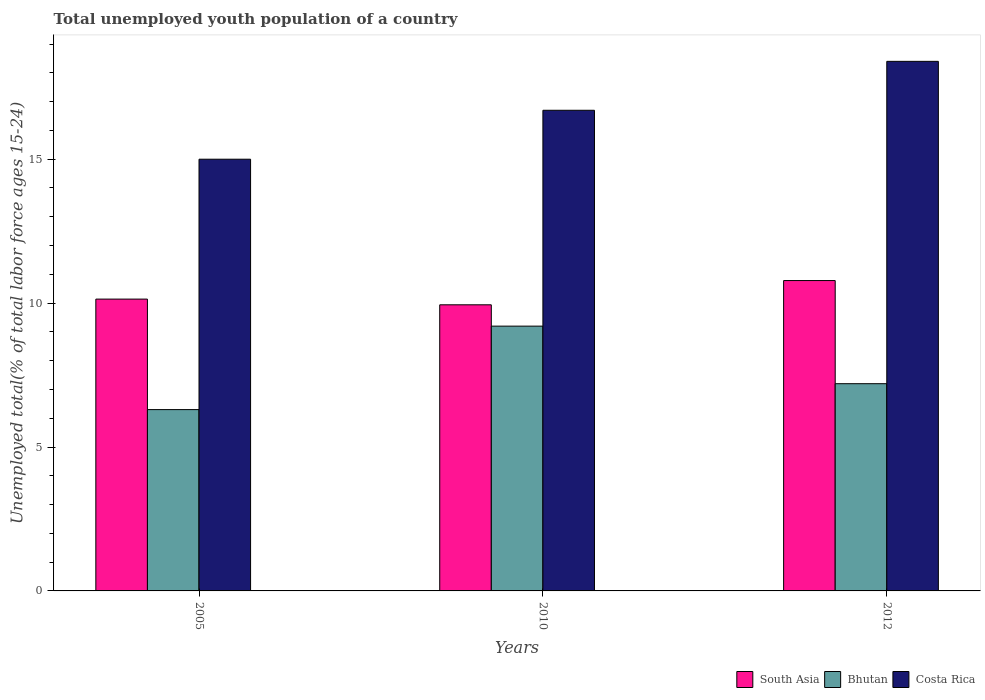How many different coloured bars are there?
Your answer should be compact. 3. How many groups of bars are there?
Your answer should be compact. 3. Are the number of bars on each tick of the X-axis equal?
Provide a short and direct response. Yes. How many bars are there on the 1st tick from the left?
Offer a very short reply. 3. How many bars are there on the 1st tick from the right?
Give a very brief answer. 3. In how many cases, is the number of bars for a given year not equal to the number of legend labels?
Keep it short and to the point. 0. What is the percentage of total unemployed youth population of a country in Bhutan in 2012?
Offer a terse response. 7.2. Across all years, what is the maximum percentage of total unemployed youth population of a country in Costa Rica?
Ensure brevity in your answer.  18.4. Across all years, what is the minimum percentage of total unemployed youth population of a country in Bhutan?
Offer a very short reply. 6.3. In which year was the percentage of total unemployed youth population of a country in Bhutan maximum?
Provide a short and direct response. 2010. In which year was the percentage of total unemployed youth population of a country in Bhutan minimum?
Ensure brevity in your answer.  2005. What is the total percentage of total unemployed youth population of a country in South Asia in the graph?
Provide a short and direct response. 30.86. What is the difference between the percentage of total unemployed youth population of a country in Costa Rica in 2005 and that in 2010?
Ensure brevity in your answer.  -1.7. What is the difference between the percentage of total unemployed youth population of a country in South Asia in 2010 and the percentage of total unemployed youth population of a country in Bhutan in 2005?
Offer a very short reply. 3.64. What is the average percentage of total unemployed youth population of a country in South Asia per year?
Ensure brevity in your answer.  10.29. In the year 2005, what is the difference between the percentage of total unemployed youth population of a country in Costa Rica and percentage of total unemployed youth population of a country in Bhutan?
Your response must be concise. 8.7. In how many years, is the percentage of total unemployed youth population of a country in Costa Rica greater than 16 %?
Provide a short and direct response. 2. What is the ratio of the percentage of total unemployed youth population of a country in South Asia in 2010 to that in 2012?
Your answer should be compact. 0.92. Is the difference between the percentage of total unemployed youth population of a country in Costa Rica in 2005 and 2010 greater than the difference between the percentage of total unemployed youth population of a country in Bhutan in 2005 and 2010?
Your answer should be compact. Yes. What is the difference between the highest and the second highest percentage of total unemployed youth population of a country in Bhutan?
Give a very brief answer. 2. What is the difference between the highest and the lowest percentage of total unemployed youth population of a country in Bhutan?
Make the answer very short. 2.9. Is the sum of the percentage of total unemployed youth population of a country in Costa Rica in 2005 and 2010 greater than the maximum percentage of total unemployed youth population of a country in South Asia across all years?
Keep it short and to the point. Yes. What does the 3rd bar from the left in 2010 represents?
Keep it short and to the point. Costa Rica. What does the 3rd bar from the right in 2012 represents?
Your answer should be very brief. South Asia. Are all the bars in the graph horizontal?
Your response must be concise. No. How many years are there in the graph?
Offer a terse response. 3. Are the values on the major ticks of Y-axis written in scientific E-notation?
Provide a short and direct response. No. Does the graph contain any zero values?
Provide a short and direct response. No. Does the graph contain grids?
Keep it short and to the point. No. How are the legend labels stacked?
Ensure brevity in your answer.  Horizontal. What is the title of the graph?
Offer a very short reply. Total unemployed youth population of a country. What is the label or title of the Y-axis?
Offer a terse response. Unemployed total(% of total labor force ages 15-24). What is the Unemployed total(% of total labor force ages 15-24) in South Asia in 2005?
Provide a short and direct response. 10.14. What is the Unemployed total(% of total labor force ages 15-24) in Bhutan in 2005?
Your answer should be compact. 6.3. What is the Unemployed total(% of total labor force ages 15-24) of Costa Rica in 2005?
Provide a succinct answer. 15. What is the Unemployed total(% of total labor force ages 15-24) of South Asia in 2010?
Your answer should be compact. 9.94. What is the Unemployed total(% of total labor force ages 15-24) of Bhutan in 2010?
Offer a very short reply. 9.2. What is the Unemployed total(% of total labor force ages 15-24) of Costa Rica in 2010?
Keep it short and to the point. 16.7. What is the Unemployed total(% of total labor force ages 15-24) in South Asia in 2012?
Offer a very short reply. 10.78. What is the Unemployed total(% of total labor force ages 15-24) of Bhutan in 2012?
Your answer should be compact. 7.2. What is the Unemployed total(% of total labor force ages 15-24) of Costa Rica in 2012?
Offer a terse response. 18.4. Across all years, what is the maximum Unemployed total(% of total labor force ages 15-24) of South Asia?
Provide a succinct answer. 10.78. Across all years, what is the maximum Unemployed total(% of total labor force ages 15-24) in Bhutan?
Your answer should be very brief. 9.2. Across all years, what is the maximum Unemployed total(% of total labor force ages 15-24) of Costa Rica?
Ensure brevity in your answer.  18.4. Across all years, what is the minimum Unemployed total(% of total labor force ages 15-24) of South Asia?
Your response must be concise. 9.94. Across all years, what is the minimum Unemployed total(% of total labor force ages 15-24) of Bhutan?
Your response must be concise. 6.3. What is the total Unemployed total(% of total labor force ages 15-24) of South Asia in the graph?
Offer a very short reply. 30.86. What is the total Unemployed total(% of total labor force ages 15-24) in Bhutan in the graph?
Keep it short and to the point. 22.7. What is the total Unemployed total(% of total labor force ages 15-24) in Costa Rica in the graph?
Provide a succinct answer. 50.1. What is the difference between the Unemployed total(% of total labor force ages 15-24) of South Asia in 2005 and that in 2010?
Your answer should be compact. 0.2. What is the difference between the Unemployed total(% of total labor force ages 15-24) of Bhutan in 2005 and that in 2010?
Provide a short and direct response. -2.9. What is the difference between the Unemployed total(% of total labor force ages 15-24) in South Asia in 2005 and that in 2012?
Provide a short and direct response. -0.64. What is the difference between the Unemployed total(% of total labor force ages 15-24) in Bhutan in 2005 and that in 2012?
Provide a succinct answer. -0.9. What is the difference between the Unemployed total(% of total labor force ages 15-24) in South Asia in 2010 and that in 2012?
Make the answer very short. -0.84. What is the difference between the Unemployed total(% of total labor force ages 15-24) in Bhutan in 2010 and that in 2012?
Your response must be concise. 2. What is the difference between the Unemployed total(% of total labor force ages 15-24) in Costa Rica in 2010 and that in 2012?
Offer a terse response. -1.7. What is the difference between the Unemployed total(% of total labor force ages 15-24) in South Asia in 2005 and the Unemployed total(% of total labor force ages 15-24) in Bhutan in 2010?
Offer a terse response. 0.94. What is the difference between the Unemployed total(% of total labor force ages 15-24) in South Asia in 2005 and the Unemployed total(% of total labor force ages 15-24) in Costa Rica in 2010?
Keep it short and to the point. -6.56. What is the difference between the Unemployed total(% of total labor force ages 15-24) of Bhutan in 2005 and the Unemployed total(% of total labor force ages 15-24) of Costa Rica in 2010?
Provide a succinct answer. -10.4. What is the difference between the Unemployed total(% of total labor force ages 15-24) of South Asia in 2005 and the Unemployed total(% of total labor force ages 15-24) of Bhutan in 2012?
Provide a short and direct response. 2.94. What is the difference between the Unemployed total(% of total labor force ages 15-24) in South Asia in 2005 and the Unemployed total(% of total labor force ages 15-24) in Costa Rica in 2012?
Your response must be concise. -8.26. What is the difference between the Unemployed total(% of total labor force ages 15-24) of South Asia in 2010 and the Unemployed total(% of total labor force ages 15-24) of Bhutan in 2012?
Your answer should be very brief. 2.74. What is the difference between the Unemployed total(% of total labor force ages 15-24) in South Asia in 2010 and the Unemployed total(% of total labor force ages 15-24) in Costa Rica in 2012?
Offer a terse response. -8.46. What is the difference between the Unemployed total(% of total labor force ages 15-24) in Bhutan in 2010 and the Unemployed total(% of total labor force ages 15-24) in Costa Rica in 2012?
Offer a very short reply. -9.2. What is the average Unemployed total(% of total labor force ages 15-24) in South Asia per year?
Provide a short and direct response. 10.29. What is the average Unemployed total(% of total labor force ages 15-24) of Bhutan per year?
Offer a terse response. 7.57. What is the average Unemployed total(% of total labor force ages 15-24) of Costa Rica per year?
Make the answer very short. 16.7. In the year 2005, what is the difference between the Unemployed total(% of total labor force ages 15-24) in South Asia and Unemployed total(% of total labor force ages 15-24) in Bhutan?
Ensure brevity in your answer.  3.84. In the year 2005, what is the difference between the Unemployed total(% of total labor force ages 15-24) in South Asia and Unemployed total(% of total labor force ages 15-24) in Costa Rica?
Ensure brevity in your answer.  -4.86. In the year 2005, what is the difference between the Unemployed total(% of total labor force ages 15-24) of Bhutan and Unemployed total(% of total labor force ages 15-24) of Costa Rica?
Keep it short and to the point. -8.7. In the year 2010, what is the difference between the Unemployed total(% of total labor force ages 15-24) of South Asia and Unemployed total(% of total labor force ages 15-24) of Bhutan?
Keep it short and to the point. 0.74. In the year 2010, what is the difference between the Unemployed total(% of total labor force ages 15-24) in South Asia and Unemployed total(% of total labor force ages 15-24) in Costa Rica?
Offer a terse response. -6.76. In the year 2012, what is the difference between the Unemployed total(% of total labor force ages 15-24) of South Asia and Unemployed total(% of total labor force ages 15-24) of Bhutan?
Give a very brief answer. 3.58. In the year 2012, what is the difference between the Unemployed total(% of total labor force ages 15-24) of South Asia and Unemployed total(% of total labor force ages 15-24) of Costa Rica?
Offer a very short reply. -7.62. What is the ratio of the Unemployed total(% of total labor force ages 15-24) in South Asia in 2005 to that in 2010?
Offer a very short reply. 1.02. What is the ratio of the Unemployed total(% of total labor force ages 15-24) in Bhutan in 2005 to that in 2010?
Keep it short and to the point. 0.68. What is the ratio of the Unemployed total(% of total labor force ages 15-24) of Costa Rica in 2005 to that in 2010?
Provide a succinct answer. 0.9. What is the ratio of the Unemployed total(% of total labor force ages 15-24) of South Asia in 2005 to that in 2012?
Your answer should be very brief. 0.94. What is the ratio of the Unemployed total(% of total labor force ages 15-24) of Bhutan in 2005 to that in 2012?
Give a very brief answer. 0.88. What is the ratio of the Unemployed total(% of total labor force ages 15-24) in Costa Rica in 2005 to that in 2012?
Give a very brief answer. 0.82. What is the ratio of the Unemployed total(% of total labor force ages 15-24) in South Asia in 2010 to that in 2012?
Offer a very short reply. 0.92. What is the ratio of the Unemployed total(% of total labor force ages 15-24) of Bhutan in 2010 to that in 2012?
Ensure brevity in your answer.  1.28. What is the ratio of the Unemployed total(% of total labor force ages 15-24) in Costa Rica in 2010 to that in 2012?
Ensure brevity in your answer.  0.91. What is the difference between the highest and the second highest Unemployed total(% of total labor force ages 15-24) in South Asia?
Keep it short and to the point. 0.64. What is the difference between the highest and the second highest Unemployed total(% of total labor force ages 15-24) of Bhutan?
Keep it short and to the point. 2. What is the difference between the highest and the lowest Unemployed total(% of total labor force ages 15-24) of South Asia?
Your answer should be compact. 0.84. What is the difference between the highest and the lowest Unemployed total(% of total labor force ages 15-24) in Costa Rica?
Keep it short and to the point. 3.4. 